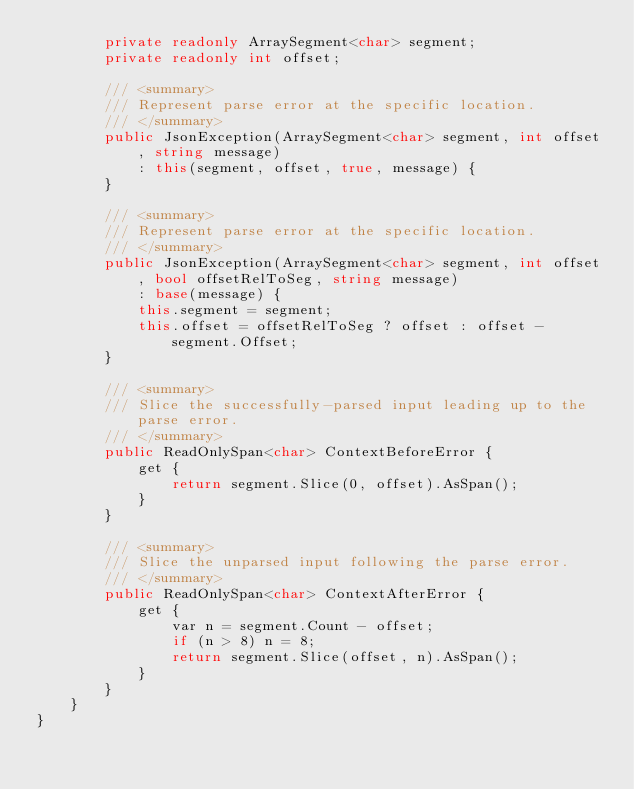<code> <loc_0><loc_0><loc_500><loc_500><_C#_>        private readonly ArraySegment<char> segment;
        private readonly int offset;

        /// <summary>
        /// Represent parse error at the specific location.
        /// </summary>
        public JsonException(ArraySegment<char> segment, int offset, string message)
            : this(segment, offset, true, message) {
        }

        /// <summary>
        /// Represent parse error at the specific location.
        /// </summary>
        public JsonException(ArraySegment<char> segment, int offset, bool offsetRelToSeg, string message)
            : base(message) {
            this.segment = segment;
            this.offset = offsetRelToSeg ? offset : offset - segment.Offset;
        }

        /// <summary>
        /// Slice the successfully-parsed input leading up to the parse error.
        /// </summary>
        public ReadOnlySpan<char> ContextBeforeError {
            get {
                return segment.Slice(0, offset).AsSpan();
            }
        }

        /// <summary>
        /// Slice the unparsed input following the parse error.
        /// </summary>
        public ReadOnlySpan<char> ContextAfterError {
            get {
                var n = segment.Count - offset;
                if (n > 8) n = 8;
                return segment.Slice(offset, n).AsSpan();
            }
        }
    }
}</code> 